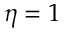<formula> <loc_0><loc_0><loc_500><loc_500>\eta = 1</formula> 